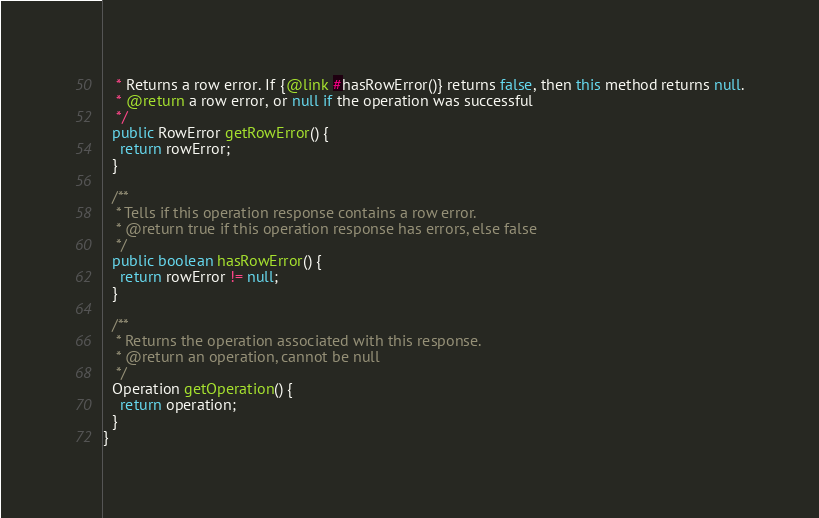Convert code to text. <code><loc_0><loc_0><loc_500><loc_500><_Java_>   * Returns a row error. If {@link #hasRowError()} returns false, then this method returns null.
   * @return a row error, or null if the operation was successful
   */
  public RowError getRowError() {
    return rowError;
  }

  /**
   * Tells if this operation response contains a row error.
   * @return true if this operation response has errors, else false
   */
  public boolean hasRowError() {
    return rowError != null;
  }

  /**
   * Returns the operation associated with this response.
   * @return an operation, cannot be null
   */
  Operation getOperation() {
    return operation;
  }
}
</code> 